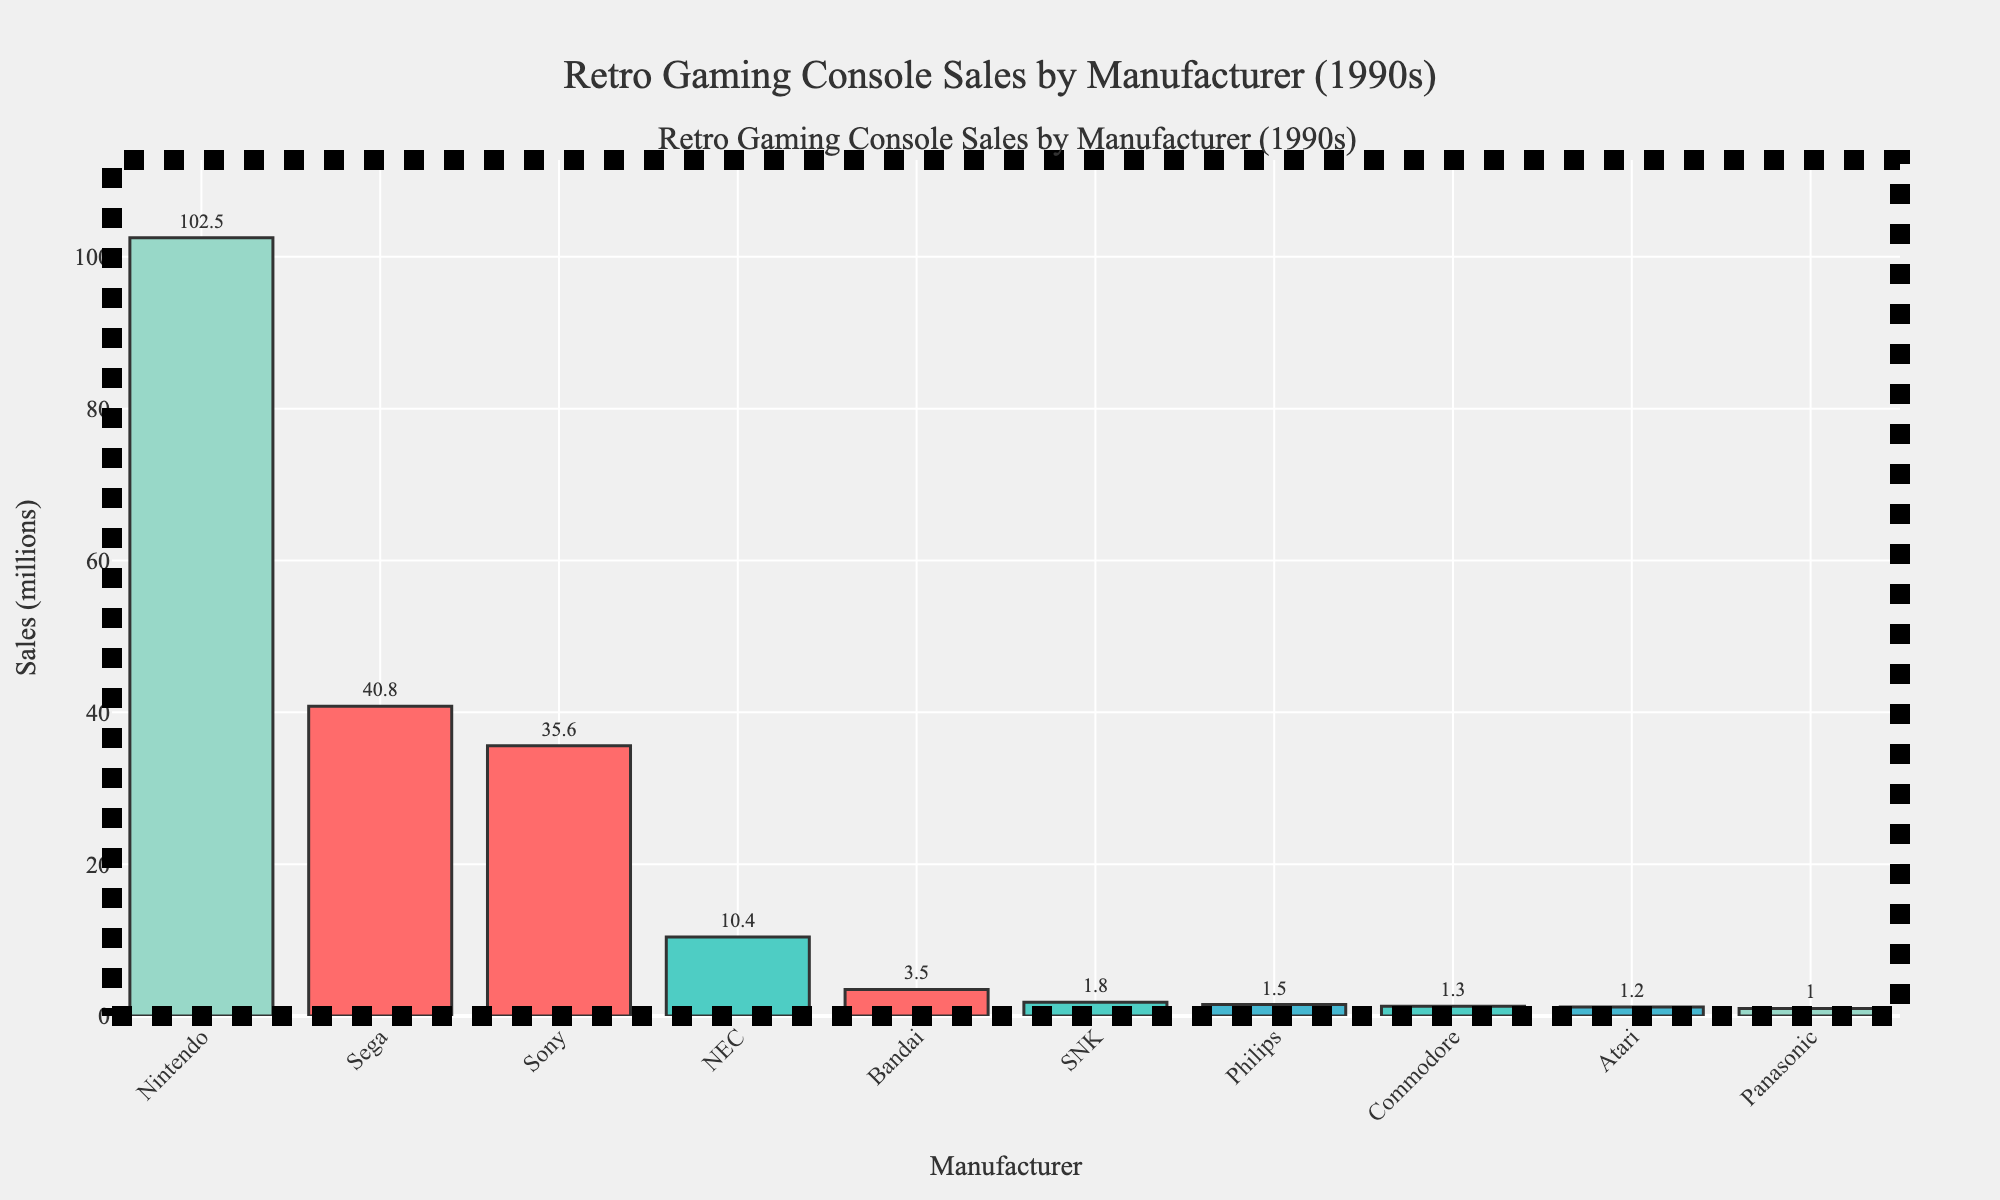Which manufacturer has the highest sales? By looking at the bar chart, we can see the tallest bar corresponds to Nintendo, indicating it has the highest sales among the manufacturers listed.
Answer: Nintendo How much greater are Nintendo's sales compared to Sega's sales? From the chart, Nintendo's sales are 102.5 million, and Sega's sales are 40.8 million. The difference is 102.5 - 40.8 = 61.7 million.
Answer: 61.7 million What is the total sales for the top three manufacturers? The top three manufacturers by sales are Nintendo (102.5 million), Sega (40.8 million), and Sony (35.6 million). The total sales are 102.5 + 40.8 + 35.6 = 178.9 million.
Answer: 178.9 million How does Philips' sales compare to Panasonic's sales? The chart shows Philips has 1.5 million in sales and Panasonic has 1.0 million. Philips' sales are higher.
Answer: Philips' sales are higher Which two manufacturers have sales closest to each other? By examining the height of the bars, Bandai (3.5 million) and SNK (1.8 million) have sales that are closer in value compared to other pairs. The difference between their sales is 3.5 - 1.8 = 1.7 million, which is relatively small.
Answer: Bandai and SNK What is the average sales across all manufacturers? The total sales of all manufacturers are 102.5 + 40.8 + 35.6 + 1.2 + 10.4 + 1.8 + 3.5 + 1.0 + 1.5 + 1.3 = 198.6 million. There are 10 manufacturers, so the average sales are 198.6 / 10 = 19.86 million.
Answer: 19.86 million What percentage of the total sales does Sony contribute? Sony's sales are 35.6 million and the total sales are 198.6 million. The percentage is (35.6 / 198.6) * 100 ≈ 17.93%.
Answer: 17.93% Which manufacturer has the lowest sales? From the chart, Panasonic has the lowest sales with 1.0 million.
Answer: Panasonic What is the range of sales values in the chart? The highest sales value is for Nintendo (102.5 million) and the lowest is for Panasonic (1.0 million). The range is 102.5 - 1.0 = 101.5 million.
Answer: 101.5 million What is the difference in sales between the manufacturers with the second and third highest sales? Sega has the second highest sales at 40.8 million and Sony the third highest at 35.6 million. The difference in their sales is 40.8 - 35.6 = 5.2 million.
Answer: 5.2 million 